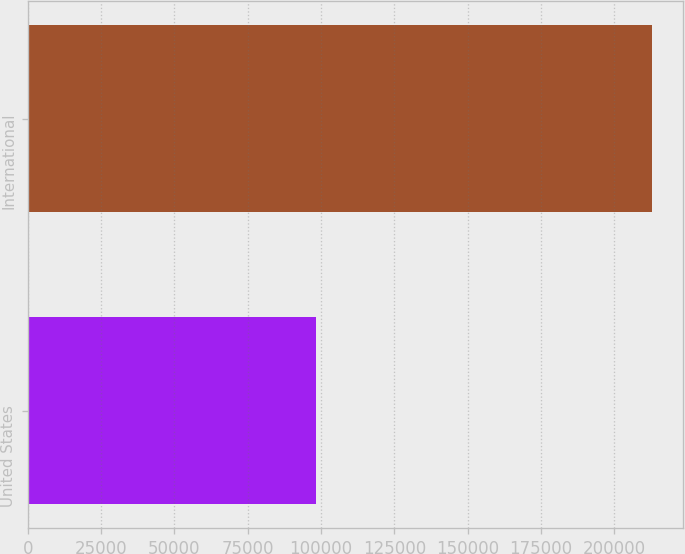Convert chart to OTSL. <chart><loc_0><loc_0><loc_500><loc_500><bar_chart><fcel>United States<fcel>International<nl><fcel>98180<fcel>212733<nl></chart> 